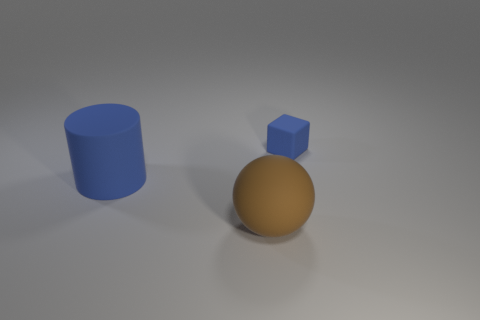What number of other objects are there of the same color as the block?
Offer a terse response. 1. Is the number of matte objects on the left side of the tiny rubber thing greater than the number of tiny cyan shiny cylinders?
Keep it short and to the point. Yes. How many objects are either things that are right of the big brown object or tiny rubber cubes?
Provide a short and direct response. 1. What number of other objects are there of the same size as the blue cube?
Make the answer very short. 0. Are there an equal number of brown balls that are to the right of the large brown rubber ball and tiny objects to the left of the small blue matte thing?
Offer a terse response. Yes. Are there any other things that have the same shape as the brown thing?
Offer a very short reply. No. Is the color of the big object that is to the left of the brown rubber ball the same as the tiny object?
Make the answer very short. Yes. How many cyan spheres are the same material as the blue cube?
Your response must be concise. 0. There is a big matte thing right of the large rubber thing to the left of the brown rubber sphere; is there a blue thing that is on the right side of it?
Give a very brief answer. Yes. There is a small blue rubber thing; what shape is it?
Make the answer very short. Cube. 